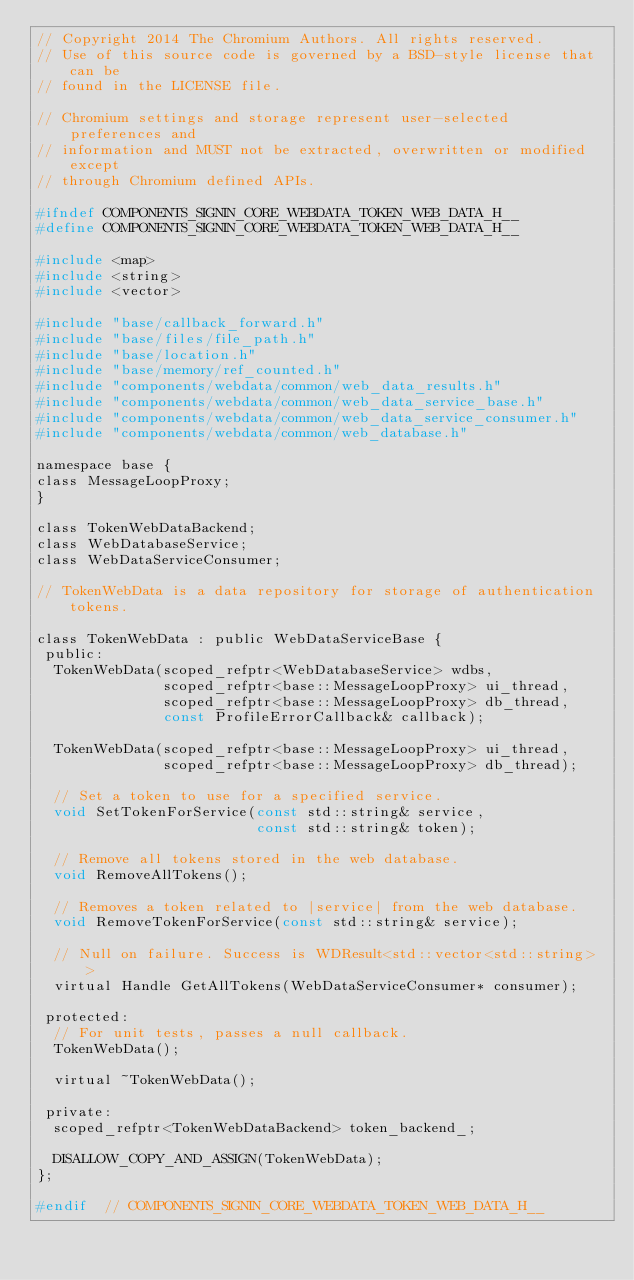<code> <loc_0><loc_0><loc_500><loc_500><_C_>// Copyright 2014 The Chromium Authors. All rights reserved.
// Use of this source code is governed by a BSD-style license that can be
// found in the LICENSE file.

// Chromium settings and storage represent user-selected preferences and
// information and MUST not be extracted, overwritten or modified except
// through Chromium defined APIs.

#ifndef COMPONENTS_SIGNIN_CORE_WEBDATA_TOKEN_WEB_DATA_H__
#define COMPONENTS_SIGNIN_CORE_WEBDATA_TOKEN_WEB_DATA_H__

#include <map>
#include <string>
#include <vector>

#include "base/callback_forward.h"
#include "base/files/file_path.h"
#include "base/location.h"
#include "base/memory/ref_counted.h"
#include "components/webdata/common/web_data_results.h"
#include "components/webdata/common/web_data_service_base.h"
#include "components/webdata/common/web_data_service_consumer.h"
#include "components/webdata/common/web_database.h"

namespace base {
class MessageLoopProxy;
}

class TokenWebDataBackend;
class WebDatabaseService;
class WebDataServiceConsumer;

// TokenWebData is a data repository for storage of authentication tokens.

class TokenWebData : public WebDataServiceBase {
 public:
  TokenWebData(scoped_refptr<WebDatabaseService> wdbs,
               scoped_refptr<base::MessageLoopProxy> ui_thread,
               scoped_refptr<base::MessageLoopProxy> db_thread,
               const ProfileErrorCallback& callback);

  TokenWebData(scoped_refptr<base::MessageLoopProxy> ui_thread,
               scoped_refptr<base::MessageLoopProxy> db_thread);

  // Set a token to use for a specified service.
  void SetTokenForService(const std::string& service,
                          const std::string& token);

  // Remove all tokens stored in the web database.
  void RemoveAllTokens();

  // Removes a token related to |service| from the web database.
  void RemoveTokenForService(const std::string& service);

  // Null on failure. Success is WDResult<std::vector<std::string> >
  virtual Handle GetAllTokens(WebDataServiceConsumer* consumer);

 protected:
  // For unit tests, passes a null callback.
  TokenWebData();

  virtual ~TokenWebData();

 private:
  scoped_refptr<TokenWebDataBackend> token_backend_;

  DISALLOW_COPY_AND_ASSIGN(TokenWebData);
};

#endif  // COMPONENTS_SIGNIN_CORE_WEBDATA_TOKEN_WEB_DATA_H__
</code> 